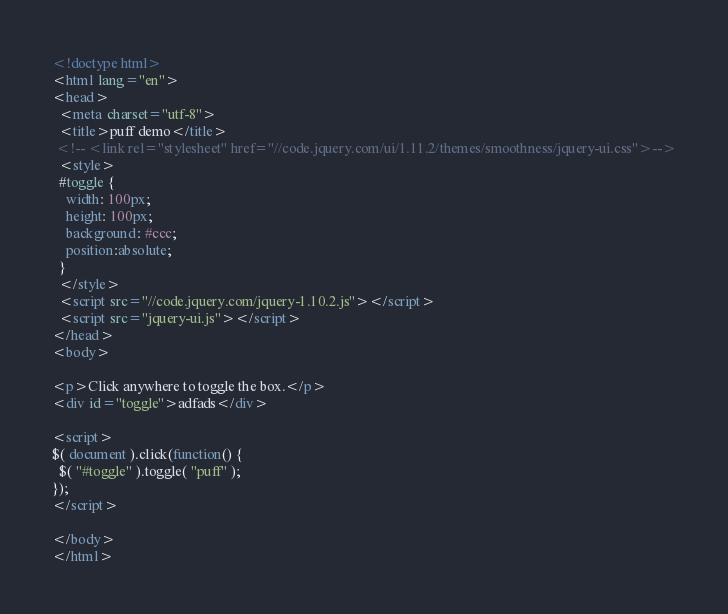Convert code to text. <code><loc_0><loc_0><loc_500><loc_500><_HTML_><!doctype html>
<html lang="en">
<head>
  <meta charset="utf-8">
  <title>puff demo</title>
 <!-- <link rel="stylesheet" href="//code.jquery.com/ui/1.11.2/themes/smoothness/jquery-ui.css">-->
  <style>
  #toggle {
    width: 100px;
    height: 100px;
    background: #ccc;
	position:absolute;
  }
  </style>
  <script src="//code.jquery.com/jquery-1.10.2.js"></script>
  <script src="jquery-ui.js"></script>
</head>
<body>
 
<p>Click anywhere to toggle the box.</p>
<div id="toggle">adfads</div>
 
<script>
$( document ).click(function() {
  $( "#toggle" ).toggle( "puff" );
});
</script>
 
</body>
</html></code> 